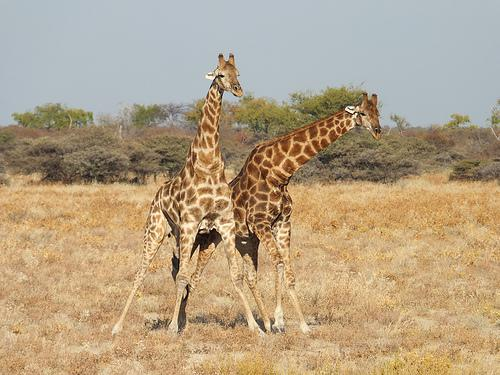Question: what are the animals in this picture called?
Choices:
A. Zebras.
B. Horses.
C. Giraffes.
D. Dingos.
Answer with the letter. Answer: C Question: where was this photo taken?
Choices:
A. Antarctica.
B. In nature.
C. Inner city.
D. Office building.
Answer with the letter. Answer: B Question: how many giraffes are visible?
Choices:
A. 1.
B. 2.
C. 3.
D. 4.
Answer with the letter. Answer: B Question: what design are these giraffes covered in?
Choices:
A. Spots.
B. Squares.
C. Stripes.
D. Checkers.
Answer with the letter. Answer: A Question: what color are the giraffes?
Choices:
A. Orange.
B. Red.
C. Brown and yellow.
D. White.
Answer with the letter. Answer: C 